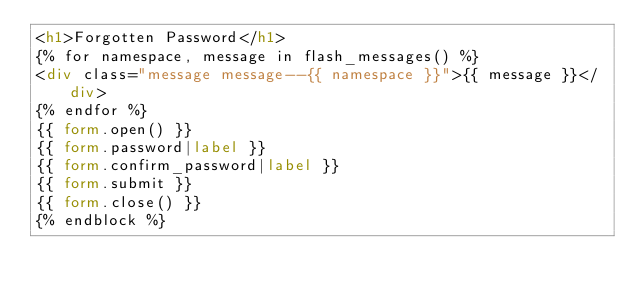<code> <loc_0><loc_0><loc_500><loc_500><_HTML_><h1>Forgotten Password</h1>
{% for namespace, message in flash_messages() %}
<div class="message message--{{ namespace }}">{{ message }}</div>
{% endfor %}
{{ form.open() }}
{{ form.password|label }}
{{ form.confirm_password|label }}
{{ form.submit }}
{{ form.close() }}
{% endblock %}
</code> 